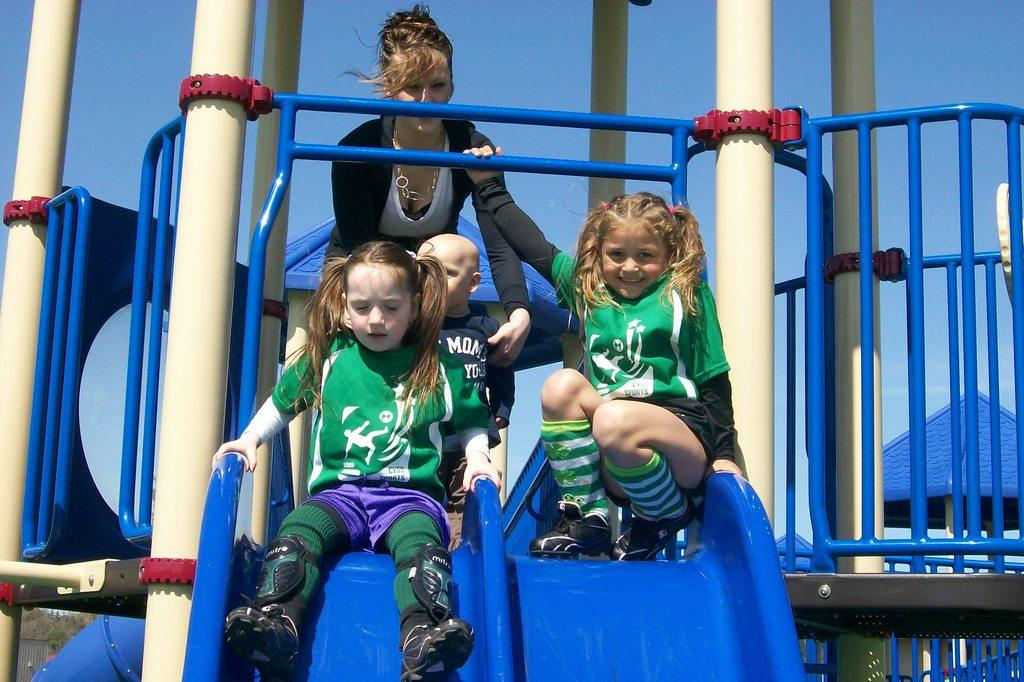What are the people doing in the image? The people are on the sliders in the image. What objects can be seen in the image besides the sliders? There are poles, a grille, and tents visible in the image. What is visible in the background of the image? The sky is visible in the background of the image. What type of music can be heard coming from the dock in the image? There is no dock present in the image, so it is not possible to determine what type of music might be heard. 